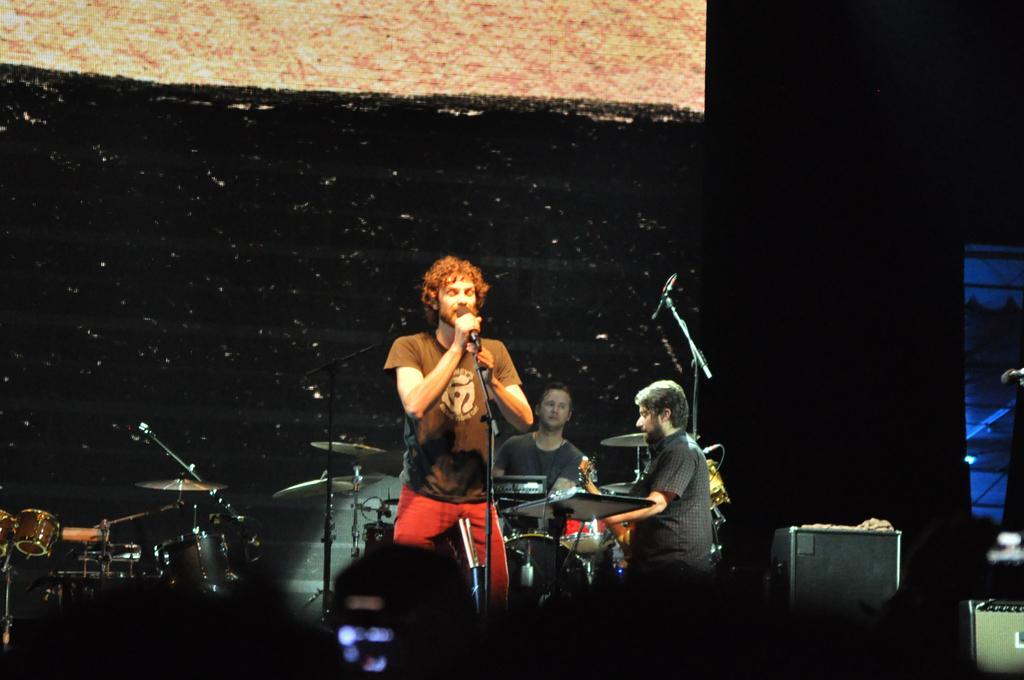Describe this image in one or two sentences. In this image I can't see there are group of people among them a man is singing a song in front of a microphone and rest of them are playing musical instruments. 